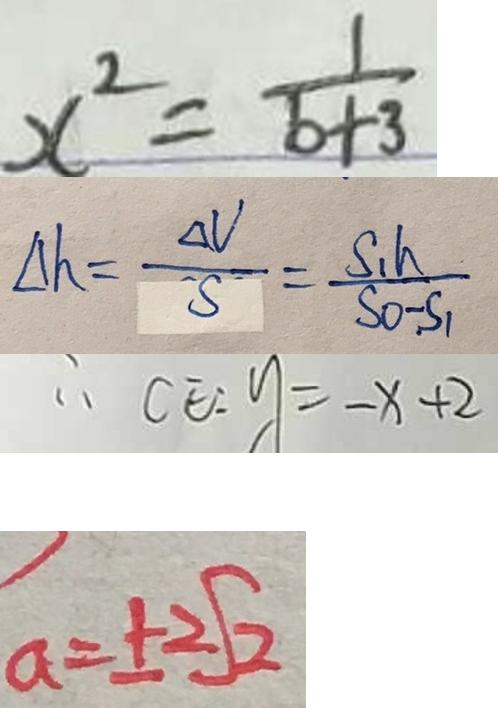Convert formula to latex. <formula><loc_0><loc_0><loc_500><loc_500>x ^ { 2 } = \frac { 1 } { b + 3 } 
 \Delta h = \frac { \Delta V } { S } = \frac { S _ { 1 } } { S _ { 0 } - S _ { 1 } } 
 \therefore C E : y = - x + 2 
 a = \pm 2 \sqrt { 2 }</formula> 